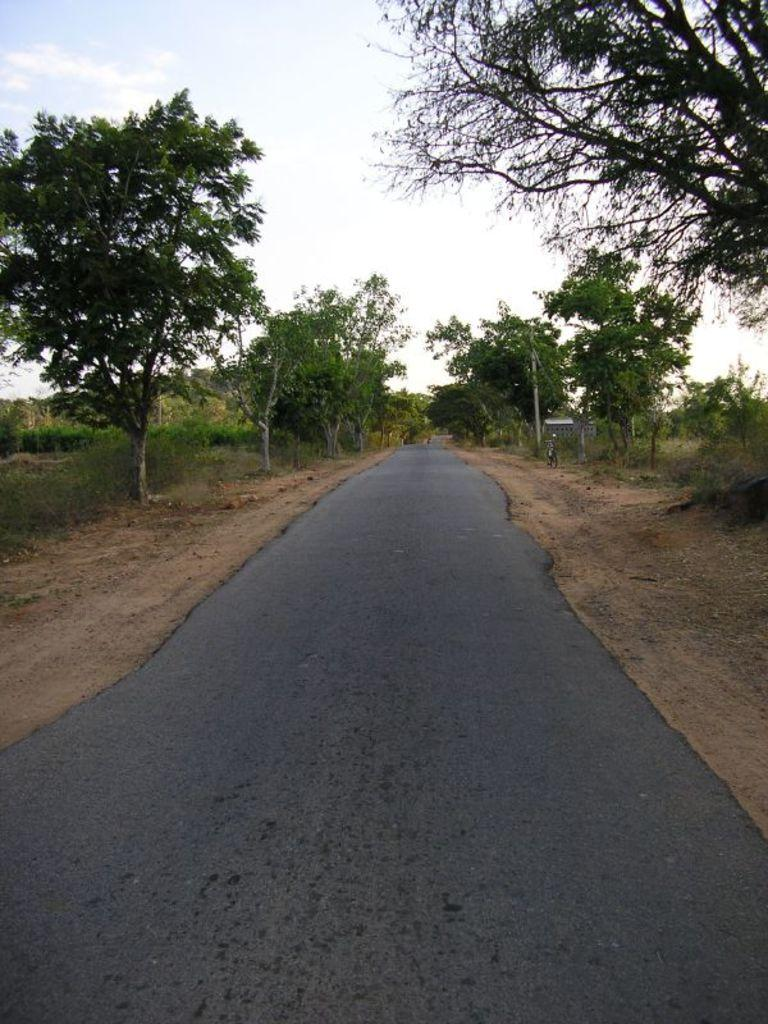What is the main feature in the center of the image? There is a road in the center of the image. What can be seen in the background of the image? There are trees in the background of the image. What object is visible in the image that is not a part of the road or trees? There is a pole visible in the image. What mode of transportation can be seen in the image? A bicycle is present in the image. What is visible at the top of the image? The sky is visible at the top of the image. How many cacti are growing on the side of the road in the image? There are no cacti visible in the image; only trees can be seen in the background. What type of bird is perched on the pole in the image? There is no bird present on the pole or anywhere else in the image. 